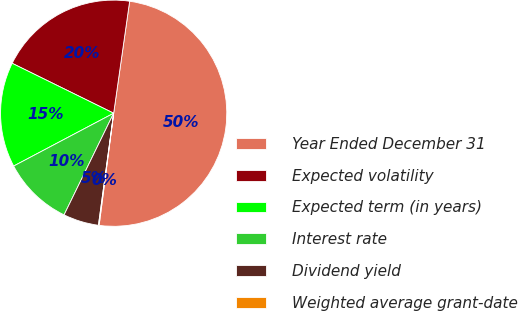Convert chart to OTSL. <chart><loc_0><loc_0><loc_500><loc_500><pie_chart><fcel>Year Ended December 31<fcel>Expected volatility<fcel>Expected term (in years)<fcel>Interest rate<fcel>Dividend yield<fcel>Weighted average grant-date<nl><fcel>49.79%<fcel>19.98%<fcel>15.01%<fcel>10.04%<fcel>5.07%<fcel>0.1%<nl></chart> 